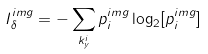<formula> <loc_0><loc_0><loc_500><loc_500>I ^ { i m g } _ { \delta } = - \sum _ { k _ { y } ^ { i } } p ^ { i m g } _ { i } \log _ { 2 } [ p ^ { i m g } _ { i } ]</formula> 